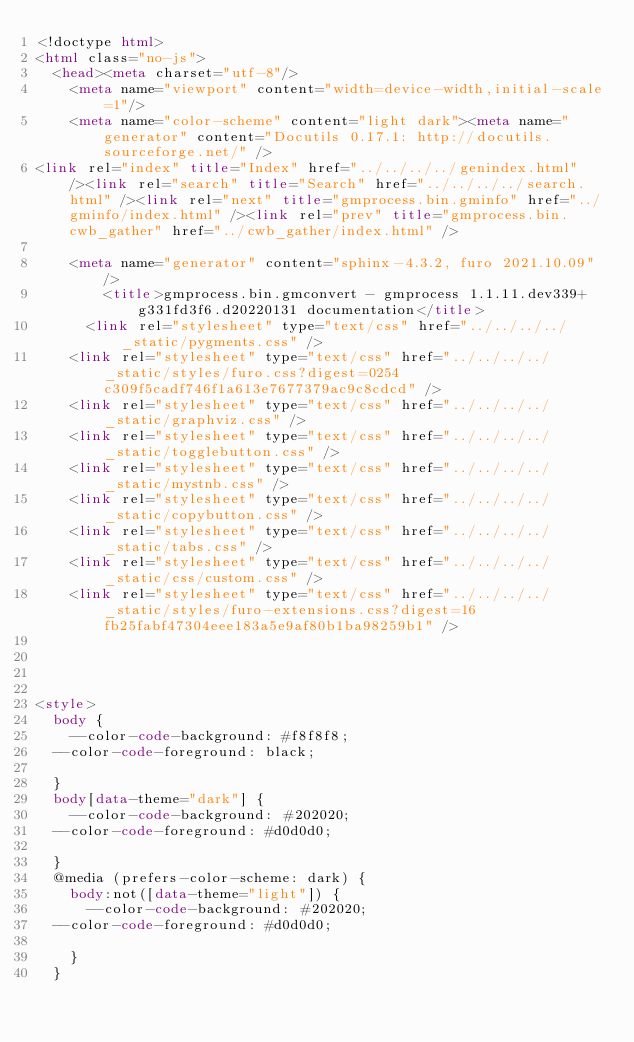Convert code to text. <code><loc_0><loc_0><loc_500><loc_500><_HTML_><!doctype html>
<html class="no-js">
  <head><meta charset="utf-8"/>
    <meta name="viewport" content="width=device-width,initial-scale=1"/>
    <meta name="color-scheme" content="light dark"><meta name="generator" content="Docutils 0.17.1: http://docutils.sourceforge.net/" />
<link rel="index" title="Index" href="../../../../genindex.html" /><link rel="search" title="Search" href="../../../../search.html" /><link rel="next" title="gmprocess.bin.gminfo" href="../gminfo/index.html" /><link rel="prev" title="gmprocess.bin.cwb_gather" href="../cwb_gather/index.html" />

    <meta name="generator" content="sphinx-4.3.2, furo 2021.10.09"/>
        <title>gmprocess.bin.gmconvert - gmprocess 1.1.11.dev339+g331fd3f6.d20220131 documentation</title>
      <link rel="stylesheet" type="text/css" href="../../../../_static/pygments.css" />
    <link rel="stylesheet" type="text/css" href="../../../../_static/styles/furo.css?digest=0254c309f5cadf746f1a613e7677379ac9c8cdcd" />
    <link rel="stylesheet" type="text/css" href="../../../../_static/graphviz.css" />
    <link rel="stylesheet" type="text/css" href="../../../../_static/togglebutton.css" />
    <link rel="stylesheet" type="text/css" href="../../../../_static/mystnb.css" />
    <link rel="stylesheet" type="text/css" href="../../../../_static/copybutton.css" />
    <link rel="stylesheet" type="text/css" href="../../../../_static/tabs.css" />
    <link rel="stylesheet" type="text/css" href="../../../../_static/css/custom.css" />
    <link rel="stylesheet" type="text/css" href="../../../../_static/styles/furo-extensions.css?digest=16fb25fabf47304eee183a5e9af80b1ba98259b1" />
    
    


<style>
  body {
    --color-code-background: #f8f8f8;
  --color-code-foreground: black;
  
  }
  body[data-theme="dark"] {
    --color-code-background: #202020;
  --color-code-foreground: #d0d0d0;
  
  }
  @media (prefers-color-scheme: dark) {
    body:not([data-theme="light"]) {
      --color-code-background: #202020;
  --color-code-foreground: #d0d0d0;
  
    }
  }</code> 